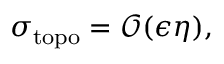<formula> <loc_0><loc_0><loc_500><loc_500>\sigma _ { t o p o } = \mathcal { O } ( \epsilon \eta ) ,</formula> 